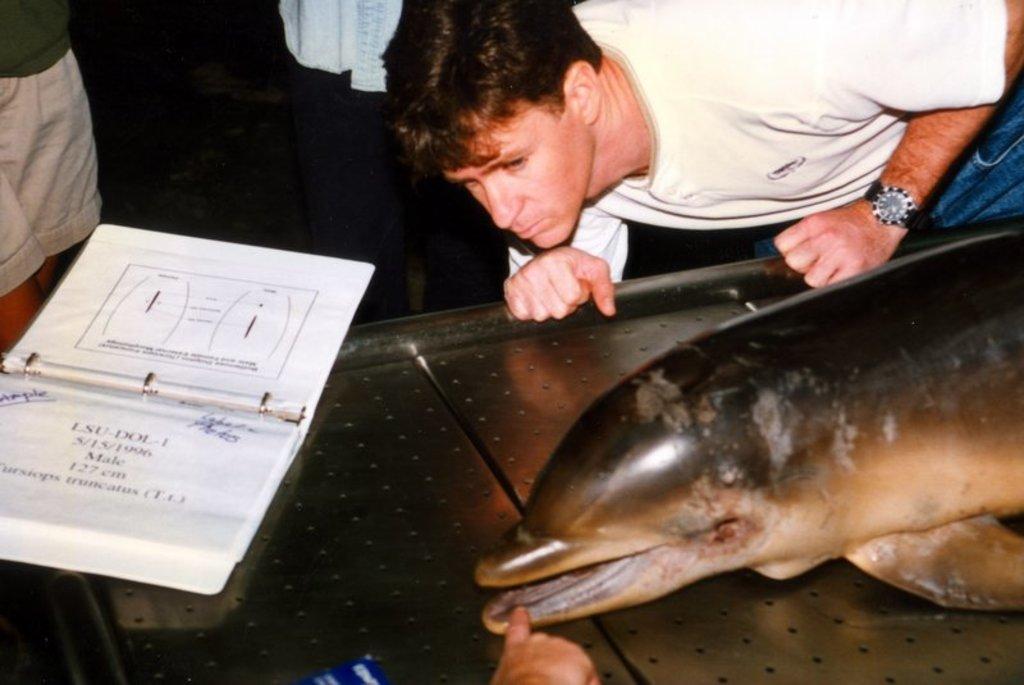Can you describe this image briefly? In this image I can see a table , on the table I can see an animal and a book and at the bottom I can see person hand which is touching to animal mouth and at the top I can see persons 